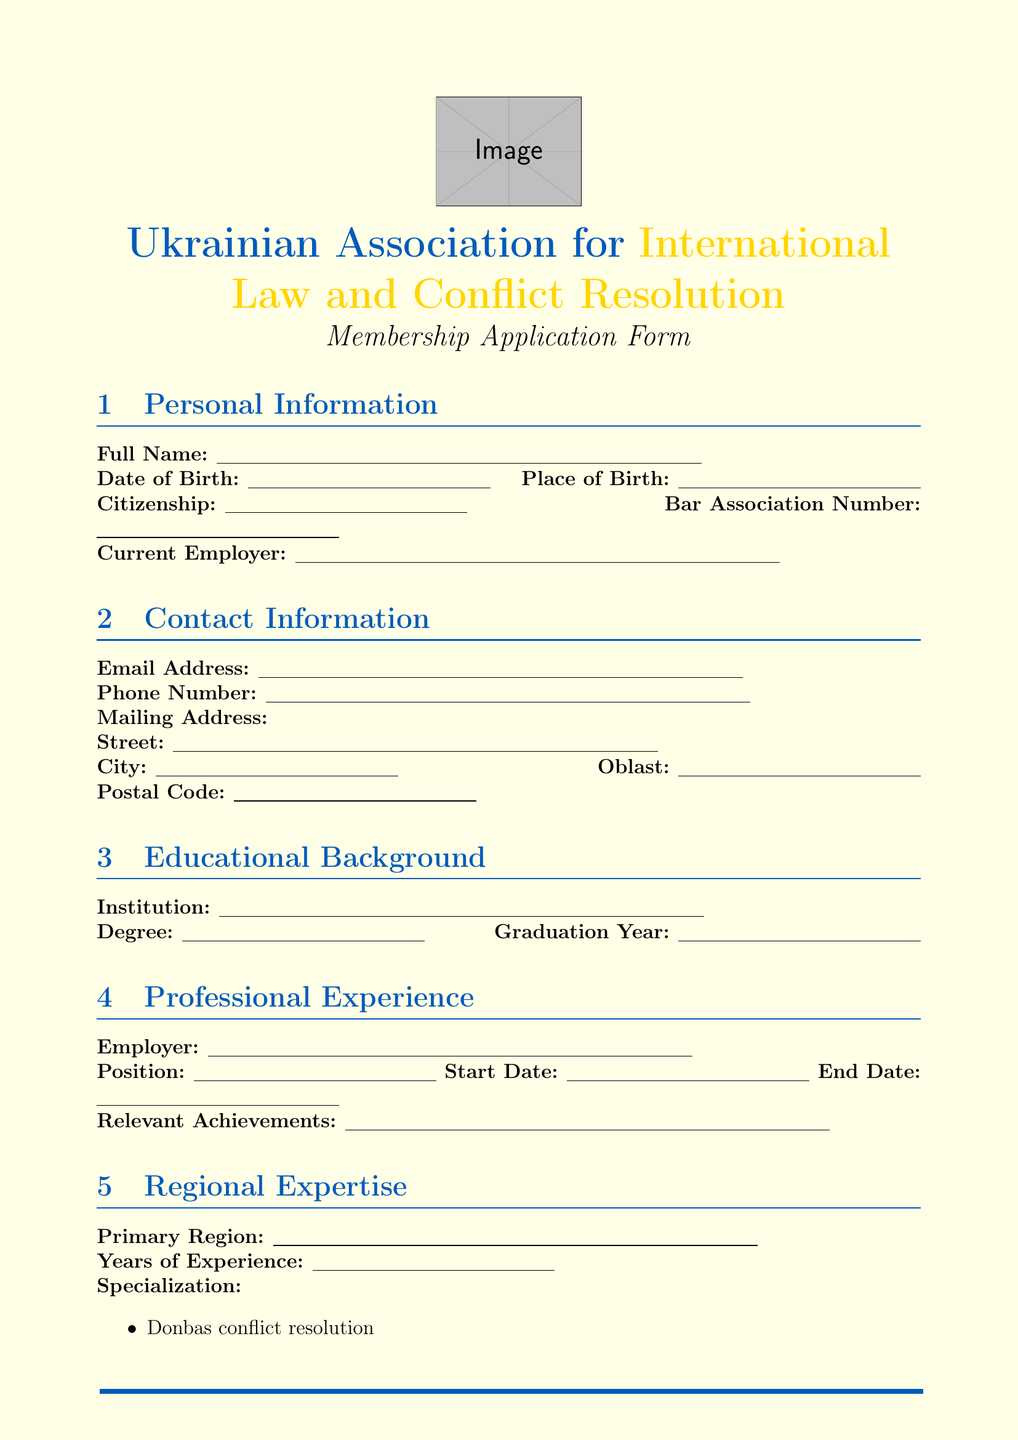What is the name of the association? The name of the association is stated in the title at the top of the document.
Answer: Ukrainian Association for International Law and Conflict Resolution What is the application fee amount? The application fee amount is specified in the Application Fee section of the document.
Answer: 500 UAH What are the three areas of specialization listed under Regional Expertise? The document lists the areas of specialization in a bullet point format under Regional Expertise.
Answer: Donbas conflict resolution, Crimea reintegration strategies, Eastern European border disputes How many international law expertise areas are mentioned? The total number of international law expertise areas is listed in the International Law Expertise section.
Answer: 4 What is the payment method options available? The document provides multiple payment method options in the Application Fee section, which can be identified by bullet points.
Answer: Bank transfer, Credit card, PayPal What contributions can members make to the association? Contributions are outlined in the Commitment to Association section of the document and listed in bullet points.
Answer: Organizing conferences, Mentoring junior members, Contributing to publications 